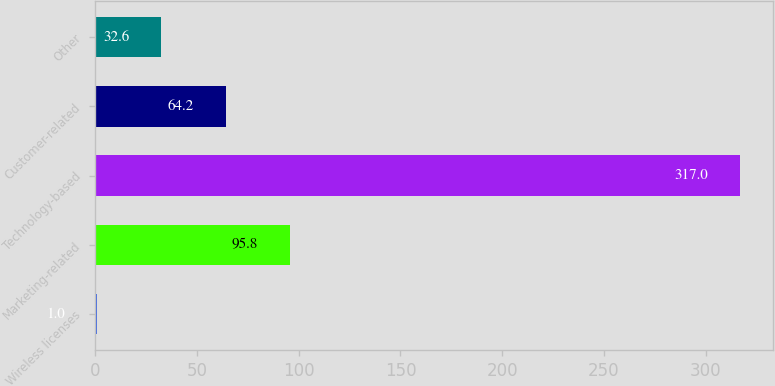Convert chart. <chart><loc_0><loc_0><loc_500><loc_500><bar_chart><fcel>Wireless licenses<fcel>Marketing-related<fcel>Technology-based<fcel>Customer-related<fcel>Other<nl><fcel>1<fcel>95.8<fcel>317<fcel>64.2<fcel>32.6<nl></chart> 